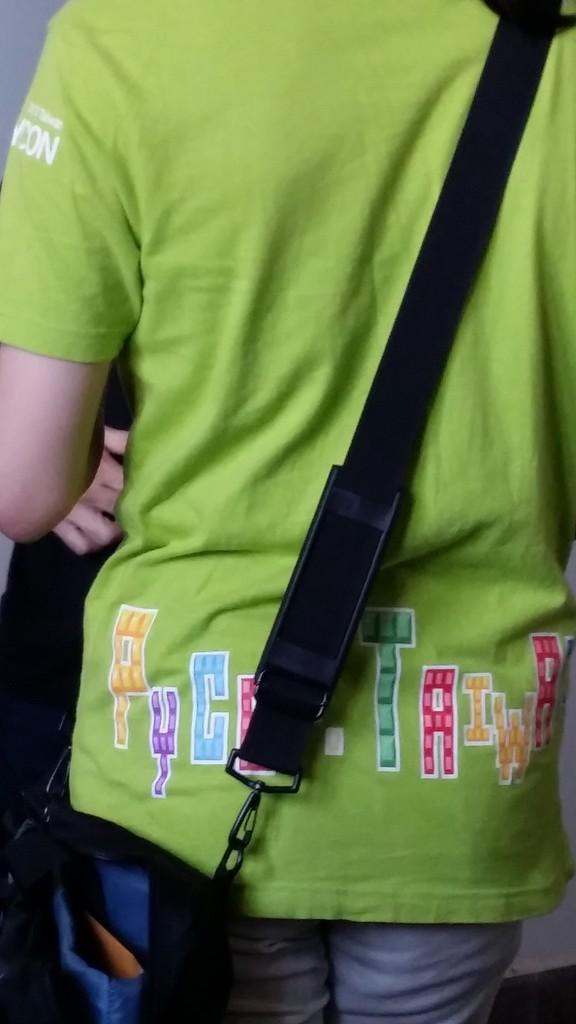Describe this image in one or two sentences. In the image there is a person and there is a bag around the shoulder of the person. 